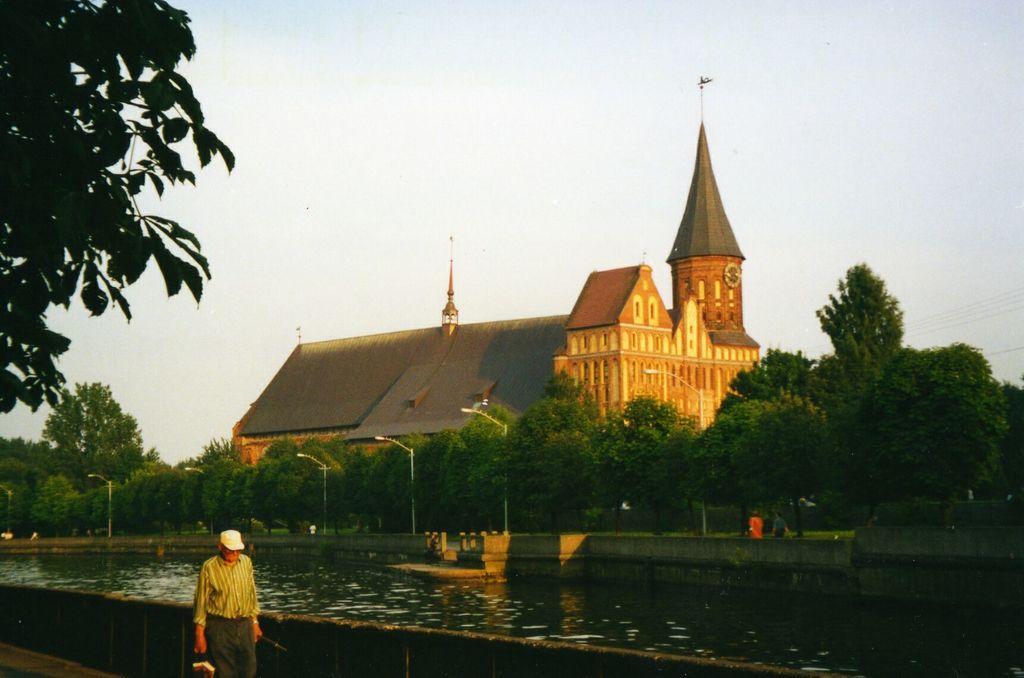Could you give a brief overview of what you see in this image? In this image in the front there is a person walking. In the center there is water. In the background there are poles, trees, persons and there is a castle and at the top there is sky. 